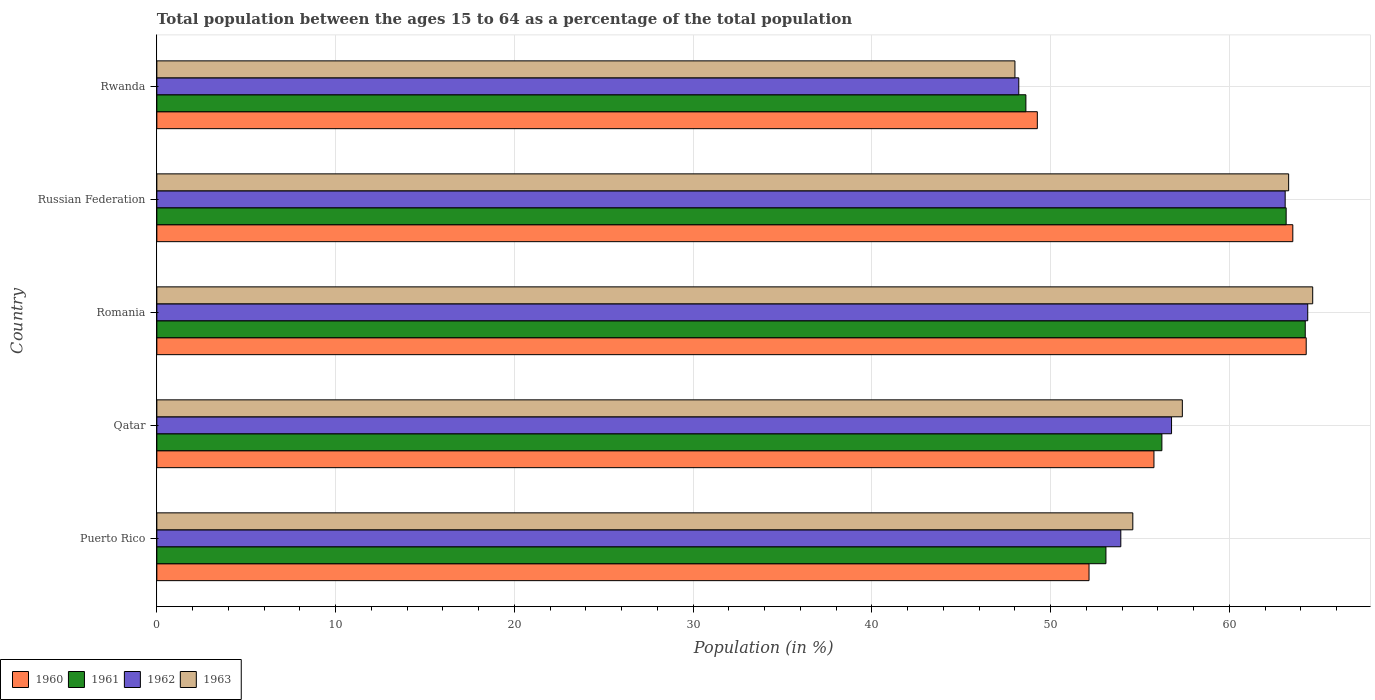How many different coloured bars are there?
Provide a succinct answer. 4. How many groups of bars are there?
Give a very brief answer. 5. What is the label of the 5th group of bars from the top?
Your answer should be very brief. Puerto Rico. In how many cases, is the number of bars for a given country not equal to the number of legend labels?
Offer a very short reply. 0. What is the percentage of the population ages 15 to 64 in 1962 in Qatar?
Offer a terse response. 56.76. Across all countries, what is the maximum percentage of the population ages 15 to 64 in 1963?
Your answer should be very brief. 64.66. Across all countries, what is the minimum percentage of the population ages 15 to 64 in 1963?
Offer a terse response. 48. In which country was the percentage of the population ages 15 to 64 in 1962 maximum?
Offer a terse response. Romania. In which country was the percentage of the population ages 15 to 64 in 1963 minimum?
Keep it short and to the point. Rwanda. What is the total percentage of the population ages 15 to 64 in 1962 in the graph?
Make the answer very short. 286.41. What is the difference between the percentage of the population ages 15 to 64 in 1963 in Russian Federation and that in Rwanda?
Offer a very short reply. 15.31. What is the difference between the percentage of the population ages 15 to 64 in 1963 in Russian Federation and the percentage of the population ages 15 to 64 in 1961 in Rwanda?
Keep it short and to the point. 14.7. What is the average percentage of the population ages 15 to 64 in 1963 per country?
Ensure brevity in your answer.  57.59. What is the difference between the percentage of the population ages 15 to 64 in 1962 and percentage of the population ages 15 to 64 in 1960 in Qatar?
Your answer should be compact. 0.98. In how many countries, is the percentage of the population ages 15 to 64 in 1963 greater than 48 ?
Provide a succinct answer. 5. What is the ratio of the percentage of the population ages 15 to 64 in 1962 in Puerto Rico to that in Rwanda?
Make the answer very short. 1.12. Is the percentage of the population ages 15 to 64 in 1963 in Puerto Rico less than that in Qatar?
Provide a short and direct response. Yes. Is the difference between the percentage of the population ages 15 to 64 in 1962 in Puerto Rico and Rwanda greater than the difference between the percentage of the population ages 15 to 64 in 1960 in Puerto Rico and Rwanda?
Your answer should be very brief. Yes. What is the difference between the highest and the second highest percentage of the population ages 15 to 64 in 1960?
Make the answer very short. 0.75. What is the difference between the highest and the lowest percentage of the population ages 15 to 64 in 1962?
Your answer should be compact. 16.17. In how many countries, is the percentage of the population ages 15 to 64 in 1962 greater than the average percentage of the population ages 15 to 64 in 1962 taken over all countries?
Your answer should be compact. 2. Is it the case that in every country, the sum of the percentage of the population ages 15 to 64 in 1961 and percentage of the population ages 15 to 64 in 1960 is greater than the sum of percentage of the population ages 15 to 64 in 1962 and percentage of the population ages 15 to 64 in 1963?
Offer a very short reply. No. What does the 3rd bar from the bottom in Russian Federation represents?
Provide a succinct answer. 1962. Is it the case that in every country, the sum of the percentage of the population ages 15 to 64 in 1960 and percentage of the population ages 15 to 64 in 1961 is greater than the percentage of the population ages 15 to 64 in 1963?
Offer a terse response. Yes. Are all the bars in the graph horizontal?
Ensure brevity in your answer.  Yes. Are the values on the major ticks of X-axis written in scientific E-notation?
Your response must be concise. No. Does the graph contain grids?
Your answer should be compact. Yes. How are the legend labels stacked?
Give a very brief answer. Horizontal. What is the title of the graph?
Ensure brevity in your answer.  Total population between the ages 15 to 64 as a percentage of the total population. Does "1971" appear as one of the legend labels in the graph?
Your answer should be very brief. No. What is the label or title of the X-axis?
Ensure brevity in your answer.  Population (in %). What is the label or title of the Y-axis?
Provide a short and direct response. Country. What is the Population (in %) of 1960 in Puerto Rico?
Provide a short and direct response. 52.15. What is the Population (in %) of 1961 in Puerto Rico?
Provide a short and direct response. 53.09. What is the Population (in %) in 1962 in Puerto Rico?
Provide a succinct answer. 53.93. What is the Population (in %) in 1963 in Puerto Rico?
Your answer should be very brief. 54.6. What is the Population (in %) of 1960 in Qatar?
Offer a very short reply. 55.78. What is the Population (in %) of 1961 in Qatar?
Ensure brevity in your answer.  56.22. What is the Population (in %) of 1962 in Qatar?
Offer a terse response. 56.76. What is the Population (in %) in 1963 in Qatar?
Your answer should be compact. 57.37. What is the Population (in %) of 1960 in Romania?
Offer a terse response. 64.3. What is the Population (in %) of 1961 in Romania?
Your answer should be compact. 64.24. What is the Population (in %) of 1962 in Romania?
Keep it short and to the point. 64.38. What is the Population (in %) in 1963 in Romania?
Provide a short and direct response. 64.66. What is the Population (in %) of 1960 in Russian Federation?
Your response must be concise. 63.55. What is the Population (in %) of 1961 in Russian Federation?
Your answer should be compact. 63.18. What is the Population (in %) in 1962 in Russian Federation?
Offer a very short reply. 63.12. What is the Population (in %) in 1963 in Russian Federation?
Provide a short and direct response. 63.31. What is the Population (in %) in 1960 in Rwanda?
Your answer should be compact. 49.26. What is the Population (in %) of 1961 in Rwanda?
Keep it short and to the point. 48.62. What is the Population (in %) of 1962 in Rwanda?
Offer a very short reply. 48.22. What is the Population (in %) of 1963 in Rwanda?
Provide a succinct answer. 48. Across all countries, what is the maximum Population (in %) in 1960?
Keep it short and to the point. 64.3. Across all countries, what is the maximum Population (in %) of 1961?
Your answer should be compact. 64.24. Across all countries, what is the maximum Population (in %) in 1962?
Keep it short and to the point. 64.38. Across all countries, what is the maximum Population (in %) of 1963?
Make the answer very short. 64.66. Across all countries, what is the minimum Population (in %) of 1960?
Provide a succinct answer. 49.26. Across all countries, what is the minimum Population (in %) in 1961?
Offer a terse response. 48.62. Across all countries, what is the minimum Population (in %) in 1962?
Keep it short and to the point. 48.22. Across all countries, what is the minimum Population (in %) of 1963?
Your answer should be very brief. 48. What is the total Population (in %) in 1960 in the graph?
Your answer should be very brief. 285.03. What is the total Population (in %) of 1961 in the graph?
Your response must be concise. 285.35. What is the total Population (in %) of 1962 in the graph?
Keep it short and to the point. 286.41. What is the total Population (in %) of 1963 in the graph?
Ensure brevity in your answer.  287.94. What is the difference between the Population (in %) in 1960 in Puerto Rico and that in Qatar?
Ensure brevity in your answer.  -3.63. What is the difference between the Population (in %) of 1961 in Puerto Rico and that in Qatar?
Your response must be concise. -3.13. What is the difference between the Population (in %) of 1962 in Puerto Rico and that in Qatar?
Offer a very short reply. -2.84. What is the difference between the Population (in %) in 1963 in Puerto Rico and that in Qatar?
Provide a succinct answer. -2.77. What is the difference between the Population (in %) in 1960 in Puerto Rico and that in Romania?
Offer a very short reply. -12.15. What is the difference between the Population (in %) in 1961 in Puerto Rico and that in Romania?
Ensure brevity in your answer.  -11.15. What is the difference between the Population (in %) in 1962 in Puerto Rico and that in Romania?
Ensure brevity in your answer.  -10.46. What is the difference between the Population (in %) of 1963 in Puerto Rico and that in Romania?
Offer a very short reply. -10.06. What is the difference between the Population (in %) of 1960 in Puerto Rico and that in Russian Federation?
Your answer should be compact. -11.4. What is the difference between the Population (in %) of 1961 in Puerto Rico and that in Russian Federation?
Offer a very short reply. -10.08. What is the difference between the Population (in %) of 1962 in Puerto Rico and that in Russian Federation?
Ensure brevity in your answer.  -9.19. What is the difference between the Population (in %) in 1963 in Puerto Rico and that in Russian Federation?
Give a very brief answer. -8.72. What is the difference between the Population (in %) in 1960 in Puerto Rico and that in Rwanda?
Make the answer very short. 2.89. What is the difference between the Population (in %) in 1961 in Puerto Rico and that in Rwanda?
Give a very brief answer. 4.48. What is the difference between the Population (in %) in 1962 in Puerto Rico and that in Rwanda?
Offer a very short reply. 5.71. What is the difference between the Population (in %) of 1963 in Puerto Rico and that in Rwanda?
Your answer should be compact. 6.59. What is the difference between the Population (in %) in 1960 in Qatar and that in Romania?
Make the answer very short. -8.52. What is the difference between the Population (in %) in 1961 in Qatar and that in Romania?
Your response must be concise. -8.02. What is the difference between the Population (in %) of 1962 in Qatar and that in Romania?
Your answer should be compact. -7.62. What is the difference between the Population (in %) of 1963 in Qatar and that in Romania?
Keep it short and to the point. -7.29. What is the difference between the Population (in %) in 1960 in Qatar and that in Russian Federation?
Provide a short and direct response. -7.77. What is the difference between the Population (in %) in 1961 in Qatar and that in Russian Federation?
Make the answer very short. -6.95. What is the difference between the Population (in %) in 1962 in Qatar and that in Russian Federation?
Ensure brevity in your answer.  -6.36. What is the difference between the Population (in %) in 1963 in Qatar and that in Russian Federation?
Provide a short and direct response. -5.95. What is the difference between the Population (in %) of 1960 in Qatar and that in Rwanda?
Make the answer very short. 6.52. What is the difference between the Population (in %) of 1961 in Qatar and that in Rwanda?
Your answer should be very brief. 7.61. What is the difference between the Population (in %) in 1962 in Qatar and that in Rwanda?
Make the answer very short. 8.55. What is the difference between the Population (in %) of 1963 in Qatar and that in Rwanda?
Provide a succinct answer. 9.37. What is the difference between the Population (in %) in 1960 in Romania and that in Russian Federation?
Make the answer very short. 0.75. What is the difference between the Population (in %) of 1961 in Romania and that in Russian Federation?
Give a very brief answer. 1.07. What is the difference between the Population (in %) of 1962 in Romania and that in Russian Federation?
Provide a succinct answer. 1.26. What is the difference between the Population (in %) in 1963 in Romania and that in Russian Federation?
Your answer should be very brief. 1.35. What is the difference between the Population (in %) in 1960 in Romania and that in Rwanda?
Your answer should be very brief. 15.04. What is the difference between the Population (in %) of 1961 in Romania and that in Rwanda?
Give a very brief answer. 15.63. What is the difference between the Population (in %) of 1962 in Romania and that in Rwanda?
Keep it short and to the point. 16.17. What is the difference between the Population (in %) in 1963 in Romania and that in Rwanda?
Offer a very short reply. 16.66. What is the difference between the Population (in %) in 1960 in Russian Federation and that in Rwanda?
Provide a short and direct response. 14.29. What is the difference between the Population (in %) of 1961 in Russian Federation and that in Rwanda?
Give a very brief answer. 14.56. What is the difference between the Population (in %) in 1962 in Russian Federation and that in Rwanda?
Provide a short and direct response. 14.9. What is the difference between the Population (in %) in 1963 in Russian Federation and that in Rwanda?
Ensure brevity in your answer.  15.31. What is the difference between the Population (in %) in 1960 in Puerto Rico and the Population (in %) in 1961 in Qatar?
Your answer should be compact. -4.08. What is the difference between the Population (in %) in 1960 in Puerto Rico and the Population (in %) in 1962 in Qatar?
Your answer should be compact. -4.62. What is the difference between the Population (in %) of 1960 in Puerto Rico and the Population (in %) of 1963 in Qatar?
Give a very brief answer. -5.22. What is the difference between the Population (in %) in 1961 in Puerto Rico and the Population (in %) in 1962 in Qatar?
Give a very brief answer. -3.67. What is the difference between the Population (in %) of 1961 in Puerto Rico and the Population (in %) of 1963 in Qatar?
Make the answer very short. -4.27. What is the difference between the Population (in %) of 1962 in Puerto Rico and the Population (in %) of 1963 in Qatar?
Your answer should be very brief. -3.44. What is the difference between the Population (in %) in 1960 in Puerto Rico and the Population (in %) in 1961 in Romania?
Offer a terse response. -12.1. What is the difference between the Population (in %) in 1960 in Puerto Rico and the Population (in %) in 1962 in Romania?
Give a very brief answer. -12.24. What is the difference between the Population (in %) in 1960 in Puerto Rico and the Population (in %) in 1963 in Romania?
Your answer should be compact. -12.51. What is the difference between the Population (in %) of 1961 in Puerto Rico and the Population (in %) of 1962 in Romania?
Your answer should be compact. -11.29. What is the difference between the Population (in %) of 1961 in Puerto Rico and the Population (in %) of 1963 in Romania?
Offer a terse response. -11.57. What is the difference between the Population (in %) in 1962 in Puerto Rico and the Population (in %) in 1963 in Romania?
Make the answer very short. -10.73. What is the difference between the Population (in %) of 1960 in Puerto Rico and the Population (in %) of 1961 in Russian Federation?
Give a very brief answer. -11.03. What is the difference between the Population (in %) in 1960 in Puerto Rico and the Population (in %) in 1962 in Russian Federation?
Your answer should be compact. -10.97. What is the difference between the Population (in %) of 1960 in Puerto Rico and the Population (in %) of 1963 in Russian Federation?
Give a very brief answer. -11.17. What is the difference between the Population (in %) of 1961 in Puerto Rico and the Population (in %) of 1962 in Russian Federation?
Your answer should be very brief. -10.03. What is the difference between the Population (in %) of 1961 in Puerto Rico and the Population (in %) of 1963 in Russian Federation?
Make the answer very short. -10.22. What is the difference between the Population (in %) in 1962 in Puerto Rico and the Population (in %) in 1963 in Russian Federation?
Keep it short and to the point. -9.39. What is the difference between the Population (in %) of 1960 in Puerto Rico and the Population (in %) of 1961 in Rwanda?
Give a very brief answer. 3.53. What is the difference between the Population (in %) in 1960 in Puerto Rico and the Population (in %) in 1962 in Rwanda?
Offer a terse response. 3.93. What is the difference between the Population (in %) of 1960 in Puerto Rico and the Population (in %) of 1963 in Rwanda?
Ensure brevity in your answer.  4.14. What is the difference between the Population (in %) of 1961 in Puerto Rico and the Population (in %) of 1962 in Rwanda?
Provide a succinct answer. 4.88. What is the difference between the Population (in %) in 1961 in Puerto Rico and the Population (in %) in 1963 in Rwanda?
Provide a succinct answer. 5.09. What is the difference between the Population (in %) in 1962 in Puerto Rico and the Population (in %) in 1963 in Rwanda?
Make the answer very short. 5.92. What is the difference between the Population (in %) of 1960 in Qatar and the Population (in %) of 1961 in Romania?
Give a very brief answer. -8.46. What is the difference between the Population (in %) in 1960 in Qatar and the Population (in %) in 1962 in Romania?
Provide a short and direct response. -8.6. What is the difference between the Population (in %) of 1960 in Qatar and the Population (in %) of 1963 in Romania?
Give a very brief answer. -8.88. What is the difference between the Population (in %) in 1961 in Qatar and the Population (in %) in 1962 in Romania?
Keep it short and to the point. -8.16. What is the difference between the Population (in %) of 1961 in Qatar and the Population (in %) of 1963 in Romania?
Provide a succinct answer. -8.44. What is the difference between the Population (in %) of 1962 in Qatar and the Population (in %) of 1963 in Romania?
Make the answer very short. -7.9. What is the difference between the Population (in %) in 1960 in Qatar and the Population (in %) in 1961 in Russian Federation?
Your answer should be compact. -7.4. What is the difference between the Population (in %) of 1960 in Qatar and the Population (in %) of 1962 in Russian Federation?
Provide a succinct answer. -7.34. What is the difference between the Population (in %) in 1960 in Qatar and the Population (in %) in 1963 in Russian Federation?
Provide a short and direct response. -7.53. What is the difference between the Population (in %) of 1961 in Qatar and the Population (in %) of 1962 in Russian Federation?
Offer a very short reply. -6.9. What is the difference between the Population (in %) in 1961 in Qatar and the Population (in %) in 1963 in Russian Federation?
Your response must be concise. -7.09. What is the difference between the Population (in %) of 1962 in Qatar and the Population (in %) of 1963 in Russian Federation?
Make the answer very short. -6.55. What is the difference between the Population (in %) of 1960 in Qatar and the Population (in %) of 1961 in Rwanda?
Keep it short and to the point. 7.16. What is the difference between the Population (in %) of 1960 in Qatar and the Population (in %) of 1962 in Rwanda?
Keep it short and to the point. 7.56. What is the difference between the Population (in %) of 1960 in Qatar and the Population (in %) of 1963 in Rwanda?
Offer a very short reply. 7.78. What is the difference between the Population (in %) in 1961 in Qatar and the Population (in %) in 1962 in Rwanda?
Offer a very short reply. 8.01. What is the difference between the Population (in %) in 1961 in Qatar and the Population (in %) in 1963 in Rwanda?
Give a very brief answer. 8.22. What is the difference between the Population (in %) in 1962 in Qatar and the Population (in %) in 1963 in Rwanda?
Give a very brief answer. 8.76. What is the difference between the Population (in %) in 1960 in Romania and the Population (in %) in 1961 in Russian Federation?
Ensure brevity in your answer.  1.12. What is the difference between the Population (in %) in 1960 in Romania and the Population (in %) in 1962 in Russian Federation?
Keep it short and to the point. 1.18. What is the difference between the Population (in %) of 1960 in Romania and the Population (in %) of 1963 in Russian Federation?
Offer a very short reply. 0.98. What is the difference between the Population (in %) in 1961 in Romania and the Population (in %) in 1962 in Russian Federation?
Offer a terse response. 1.12. What is the difference between the Population (in %) of 1961 in Romania and the Population (in %) of 1963 in Russian Federation?
Provide a short and direct response. 0.93. What is the difference between the Population (in %) of 1962 in Romania and the Population (in %) of 1963 in Russian Federation?
Offer a very short reply. 1.07. What is the difference between the Population (in %) of 1960 in Romania and the Population (in %) of 1961 in Rwanda?
Provide a succinct answer. 15.68. What is the difference between the Population (in %) of 1960 in Romania and the Population (in %) of 1962 in Rwanda?
Ensure brevity in your answer.  16.08. What is the difference between the Population (in %) of 1960 in Romania and the Population (in %) of 1963 in Rwanda?
Offer a terse response. 16.29. What is the difference between the Population (in %) of 1961 in Romania and the Population (in %) of 1962 in Rwanda?
Offer a terse response. 16.03. What is the difference between the Population (in %) of 1961 in Romania and the Population (in %) of 1963 in Rwanda?
Offer a very short reply. 16.24. What is the difference between the Population (in %) in 1962 in Romania and the Population (in %) in 1963 in Rwanda?
Your answer should be compact. 16.38. What is the difference between the Population (in %) in 1960 in Russian Federation and the Population (in %) in 1961 in Rwanda?
Your answer should be very brief. 14.93. What is the difference between the Population (in %) in 1960 in Russian Federation and the Population (in %) in 1962 in Rwanda?
Your answer should be very brief. 15.33. What is the difference between the Population (in %) of 1960 in Russian Federation and the Population (in %) of 1963 in Rwanda?
Offer a terse response. 15.55. What is the difference between the Population (in %) of 1961 in Russian Federation and the Population (in %) of 1962 in Rwanda?
Provide a short and direct response. 14.96. What is the difference between the Population (in %) in 1961 in Russian Federation and the Population (in %) in 1963 in Rwanda?
Provide a succinct answer. 15.17. What is the difference between the Population (in %) of 1962 in Russian Federation and the Population (in %) of 1963 in Rwanda?
Your response must be concise. 15.12. What is the average Population (in %) in 1960 per country?
Ensure brevity in your answer.  57.01. What is the average Population (in %) in 1961 per country?
Offer a terse response. 57.07. What is the average Population (in %) of 1962 per country?
Keep it short and to the point. 57.28. What is the average Population (in %) in 1963 per country?
Your answer should be compact. 57.59. What is the difference between the Population (in %) of 1960 and Population (in %) of 1961 in Puerto Rico?
Offer a terse response. -0.95. What is the difference between the Population (in %) in 1960 and Population (in %) in 1962 in Puerto Rico?
Your response must be concise. -1.78. What is the difference between the Population (in %) of 1960 and Population (in %) of 1963 in Puerto Rico?
Offer a very short reply. -2.45. What is the difference between the Population (in %) in 1961 and Population (in %) in 1962 in Puerto Rico?
Your response must be concise. -0.83. What is the difference between the Population (in %) in 1961 and Population (in %) in 1963 in Puerto Rico?
Your answer should be compact. -1.5. What is the difference between the Population (in %) of 1962 and Population (in %) of 1963 in Puerto Rico?
Your response must be concise. -0.67. What is the difference between the Population (in %) in 1960 and Population (in %) in 1961 in Qatar?
Make the answer very short. -0.44. What is the difference between the Population (in %) in 1960 and Population (in %) in 1962 in Qatar?
Provide a short and direct response. -0.98. What is the difference between the Population (in %) of 1960 and Population (in %) of 1963 in Qatar?
Provide a short and direct response. -1.59. What is the difference between the Population (in %) in 1961 and Population (in %) in 1962 in Qatar?
Provide a short and direct response. -0.54. What is the difference between the Population (in %) of 1961 and Population (in %) of 1963 in Qatar?
Your response must be concise. -1.14. What is the difference between the Population (in %) of 1962 and Population (in %) of 1963 in Qatar?
Your response must be concise. -0.6. What is the difference between the Population (in %) of 1960 and Population (in %) of 1961 in Romania?
Make the answer very short. 0.05. What is the difference between the Population (in %) in 1960 and Population (in %) in 1962 in Romania?
Keep it short and to the point. -0.09. What is the difference between the Population (in %) of 1960 and Population (in %) of 1963 in Romania?
Your response must be concise. -0.36. What is the difference between the Population (in %) in 1961 and Population (in %) in 1962 in Romania?
Your answer should be very brief. -0.14. What is the difference between the Population (in %) of 1961 and Population (in %) of 1963 in Romania?
Provide a succinct answer. -0.42. What is the difference between the Population (in %) in 1962 and Population (in %) in 1963 in Romania?
Provide a short and direct response. -0.28. What is the difference between the Population (in %) of 1960 and Population (in %) of 1961 in Russian Federation?
Your response must be concise. 0.37. What is the difference between the Population (in %) of 1960 and Population (in %) of 1962 in Russian Federation?
Keep it short and to the point. 0.43. What is the difference between the Population (in %) of 1960 and Population (in %) of 1963 in Russian Federation?
Offer a terse response. 0.23. What is the difference between the Population (in %) in 1961 and Population (in %) in 1962 in Russian Federation?
Ensure brevity in your answer.  0.06. What is the difference between the Population (in %) in 1961 and Population (in %) in 1963 in Russian Federation?
Your response must be concise. -0.14. What is the difference between the Population (in %) in 1962 and Population (in %) in 1963 in Russian Federation?
Offer a very short reply. -0.19. What is the difference between the Population (in %) in 1960 and Population (in %) in 1961 in Rwanda?
Keep it short and to the point. 0.64. What is the difference between the Population (in %) in 1960 and Population (in %) in 1962 in Rwanda?
Your answer should be very brief. 1.04. What is the difference between the Population (in %) in 1960 and Population (in %) in 1963 in Rwanda?
Your answer should be very brief. 1.25. What is the difference between the Population (in %) of 1961 and Population (in %) of 1962 in Rwanda?
Offer a terse response. 0.4. What is the difference between the Population (in %) of 1961 and Population (in %) of 1963 in Rwanda?
Keep it short and to the point. 0.61. What is the difference between the Population (in %) in 1962 and Population (in %) in 1963 in Rwanda?
Your answer should be very brief. 0.21. What is the ratio of the Population (in %) of 1960 in Puerto Rico to that in Qatar?
Ensure brevity in your answer.  0.93. What is the ratio of the Population (in %) of 1961 in Puerto Rico to that in Qatar?
Give a very brief answer. 0.94. What is the ratio of the Population (in %) in 1963 in Puerto Rico to that in Qatar?
Your answer should be very brief. 0.95. What is the ratio of the Population (in %) of 1960 in Puerto Rico to that in Romania?
Your answer should be compact. 0.81. What is the ratio of the Population (in %) of 1961 in Puerto Rico to that in Romania?
Provide a succinct answer. 0.83. What is the ratio of the Population (in %) in 1962 in Puerto Rico to that in Romania?
Offer a very short reply. 0.84. What is the ratio of the Population (in %) in 1963 in Puerto Rico to that in Romania?
Ensure brevity in your answer.  0.84. What is the ratio of the Population (in %) of 1960 in Puerto Rico to that in Russian Federation?
Your answer should be very brief. 0.82. What is the ratio of the Population (in %) in 1961 in Puerto Rico to that in Russian Federation?
Give a very brief answer. 0.84. What is the ratio of the Population (in %) of 1962 in Puerto Rico to that in Russian Federation?
Offer a terse response. 0.85. What is the ratio of the Population (in %) of 1963 in Puerto Rico to that in Russian Federation?
Provide a succinct answer. 0.86. What is the ratio of the Population (in %) in 1960 in Puerto Rico to that in Rwanda?
Your answer should be compact. 1.06. What is the ratio of the Population (in %) in 1961 in Puerto Rico to that in Rwanda?
Your response must be concise. 1.09. What is the ratio of the Population (in %) in 1962 in Puerto Rico to that in Rwanda?
Offer a very short reply. 1.12. What is the ratio of the Population (in %) of 1963 in Puerto Rico to that in Rwanda?
Your response must be concise. 1.14. What is the ratio of the Population (in %) of 1960 in Qatar to that in Romania?
Keep it short and to the point. 0.87. What is the ratio of the Population (in %) in 1961 in Qatar to that in Romania?
Give a very brief answer. 0.88. What is the ratio of the Population (in %) of 1962 in Qatar to that in Romania?
Offer a terse response. 0.88. What is the ratio of the Population (in %) in 1963 in Qatar to that in Romania?
Keep it short and to the point. 0.89. What is the ratio of the Population (in %) of 1960 in Qatar to that in Russian Federation?
Keep it short and to the point. 0.88. What is the ratio of the Population (in %) of 1961 in Qatar to that in Russian Federation?
Your answer should be very brief. 0.89. What is the ratio of the Population (in %) of 1962 in Qatar to that in Russian Federation?
Keep it short and to the point. 0.9. What is the ratio of the Population (in %) of 1963 in Qatar to that in Russian Federation?
Ensure brevity in your answer.  0.91. What is the ratio of the Population (in %) of 1960 in Qatar to that in Rwanda?
Keep it short and to the point. 1.13. What is the ratio of the Population (in %) in 1961 in Qatar to that in Rwanda?
Your response must be concise. 1.16. What is the ratio of the Population (in %) in 1962 in Qatar to that in Rwanda?
Your answer should be compact. 1.18. What is the ratio of the Population (in %) of 1963 in Qatar to that in Rwanda?
Ensure brevity in your answer.  1.2. What is the ratio of the Population (in %) in 1960 in Romania to that in Russian Federation?
Offer a very short reply. 1.01. What is the ratio of the Population (in %) of 1961 in Romania to that in Russian Federation?
Provide a succinct answer. 1.02. What is the ratio of the Population (in %) in 1962 in Romania to that in Russian Federation?
Ensure brevity in your answer.  1.02. What is the ratio of the Population (in %) of 1963 in Romania to that in Russian Federation?
Your answer should be very brief. 1.02. What is the ratio of the Population (in %) in 1960 in Romania to that in Rwanda?
Make the answer very short. 1.31. What is the ratio of the Population (in %) in 1961 in Romania to that in Rwanda?
Make the answer very short. 1.32. What is the ratio of the Population (in %) of 1962 in Romania to that in Rwanda?
Your answer should be very brief. 1.34. What is the ratio of the Population (in %) in 1963 in Romania to that in Rwanda?
Your answer should be very brief. 1.35. What is the ratio of the Population (in %) of 1960 in Russian Federation to that in Rwanda?
Give a very brief answer. 1.29. What is the ratio of the Population (in %) of 1961 in Russian Federation to that in Rwanda?
Ensure brevity in your answer.  1.3. What is the ratio of the Population (in %) of 1962 in Russian Federation to that in Rwanda?
Offer a terse response. 1.31. What is the ratio of the Population (in %) of 1963 in Russian Federation to that in Rwanda?
Keep it short and to the point. 1.32. What is the difference between the highest and the second highest Population (in %) of 1960?
Offer a terse response. 0.75. What is the difference between the highest and the second highest Population (in %) of 1961?
Provide a short and direct response. 1.07. What is the difference between the highest and the second highest Population (in %) of 1962?
Your answer should be very brief. 1.26. What is the difference between the highest and the second highest Population (in %) in 1963?
Keep it short and to the point. 1.35. What is the difference between the highest and the lowest Population (in %) in 1960?
Ensure brevity in your answer.  15.04. What is the difference between the highest and the lowest Population (in %) of 1961?
Ensure brevity in your answer.  15.63. What is the difference between the highest and the lowest Population (in %) of 1962?
Provide a succinct answer. 16.17. What is the difference between the highest and the lowest Population (in %) in 1963?
Ensure brevity in your answer.  16.66. 